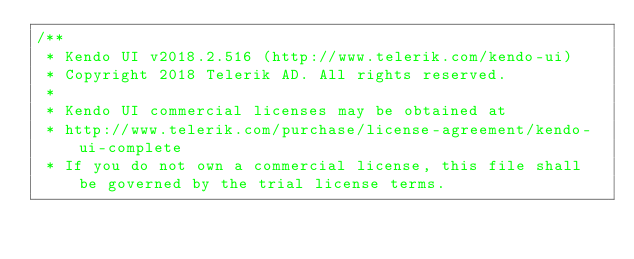<code> <loc_0><loc_0><loc_500><loc_500><_CSS_>/** 
 * Kendo UI v2018.2.516 (http://www.telerik.com/kendo-ui)                                                                                                                                               
 * Copyright 2018 Telerik AD. All rights reserved.                                                                                                                                                      
 *                                                                                                                                                                                                      
 * Kendo UI commercial licenses may be obtained at                                                                                                                                                      
 * http://www.telerik.com/purchase/license-agreement/kendo-ui-complete                                                                                                                                  
 * If you do not own a commercial license, this file shall be governed by the trial license terms.                                                                                                      
                                                                                                                                                                                                       
                                                                                                                                                                                                       
                                                                                                                                                                                                       
                                                                                                                                                                                                       
                                                                                                                                                                                                       
                                                                                                                                                                                                       
                                                                                                                                                                                                       
                                                                                                                                                                                                       
                                                                                                                                                                                                       
                                                                                                                                                                                                       
                                                                                                                                                                                                       
                                                                                                                                                                                                       
                                                                                                                                                                                                       
                                                                                                                                                                                                       
                                                                                                                                                                                                       
</code> 